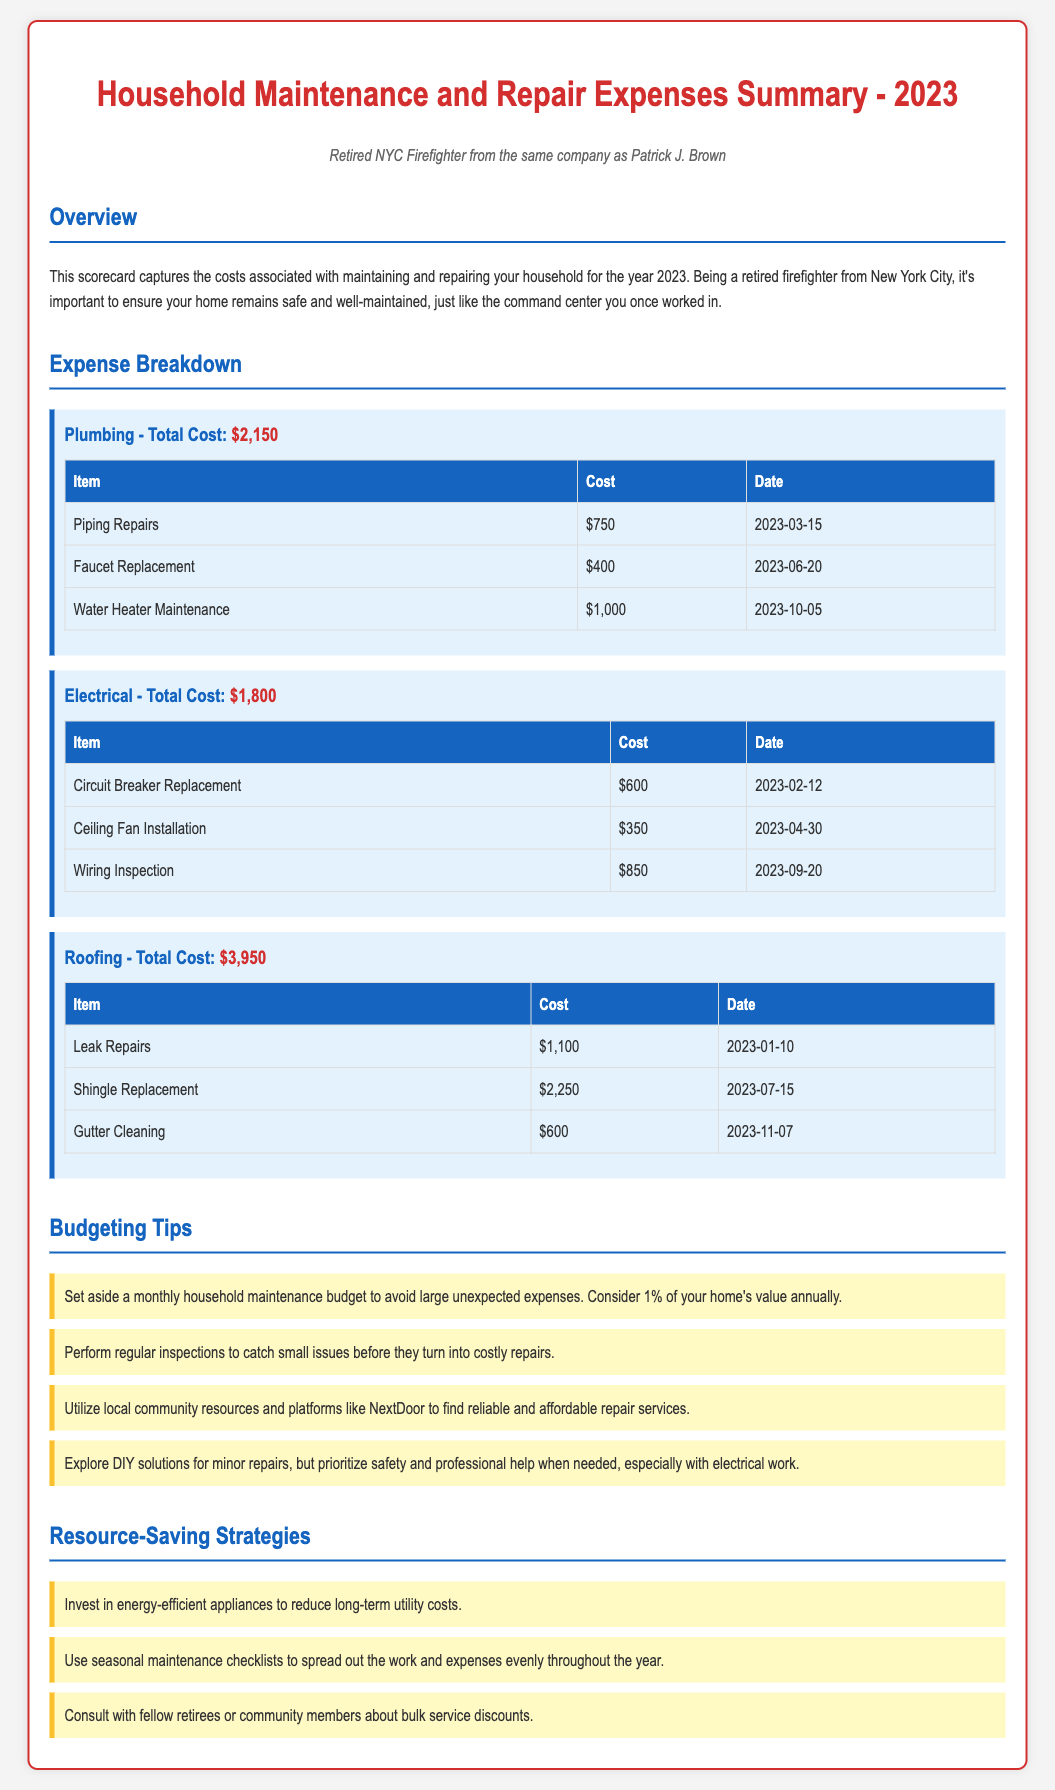what is the total cost for plumbing? The total cost for plumbing is stated under the Plumbing section, which is $2,150.
Answer: $2,150 how much did the faucet replacement cost? The cost for the faucet replacement is listed in the Plumbing table as $400.
Answer: $400 when was the ceiling fan installation done? The date for the ceiling fan installation is provided in the Electrical table as April 30, 2023.
Answer: April 30, 2023 what is one budgeting tip suggested in the document? The document suggests setting aside a monthly household maintenance budget as one of the budgeting tips.
Answer: Set aside a monthly household maintenance budget what is the total cost for roofing? The total cost for roofing is stated under the Roofing section, which is $3,950.
Answer: $3,950 how much did water heater maintenance cost? The cost for water heater maintenance is listed under the Plumbing table as $1,000.
Answer: $1,000 what is a suggested resource-saving strategy? The document mentions investing in energy-efficient appliances as a resource-saving strategy.
Answer: Invest in energy-efficient appliances what is the total spending on electrical repairs? The total cost for electrical repairs is provided under the Electrical section as $1,800.
Answer: $1,800 what item had the highest cost in roofing expenses? The item with the highest cost in roofing expenses is shingle replacement, which is $2,250.
Answer: Shingle Replacement 